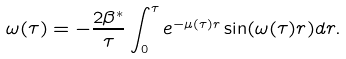Convert formula to latex. <formula><loc_0><loc_0><loc_500><loc_500>\omega ( \tau ) = - \frac { 2 \beta ^ { * } } { \tau } \int _ { 0 } ^ { \tau } e ^ { - \mu ( \tau ) r } \sin ( \omega ( \tau ) r ) d r .</formula> 